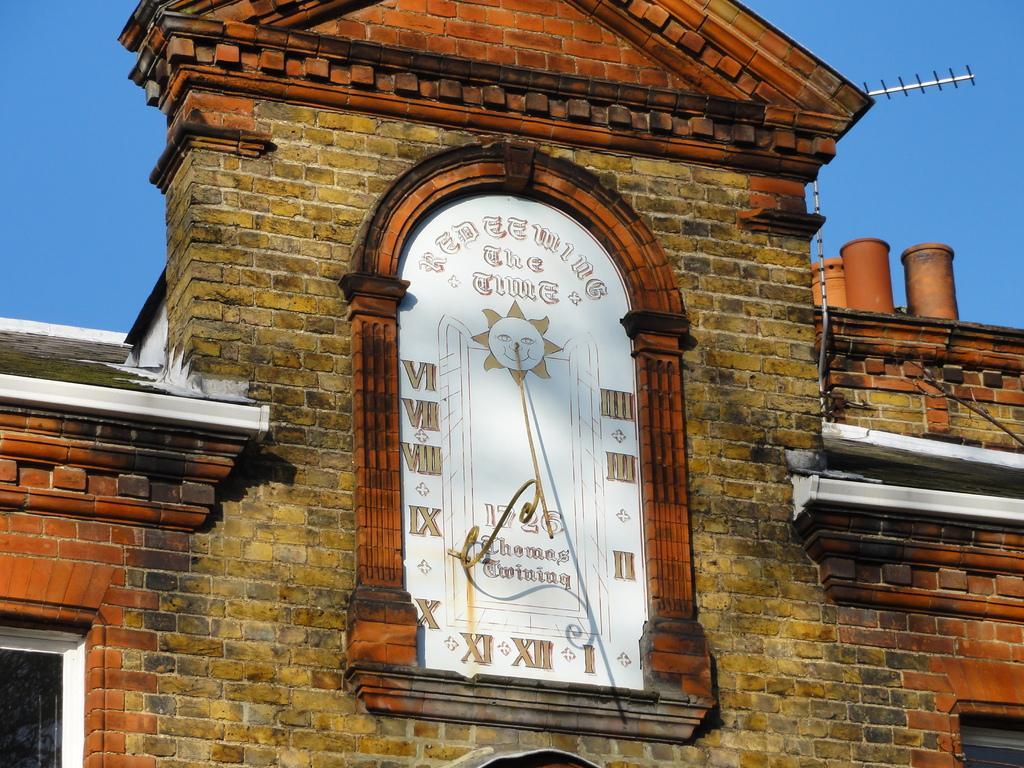<image>
Describe the image concisely. A old building with the words Redeeming the time written upon its walls. 